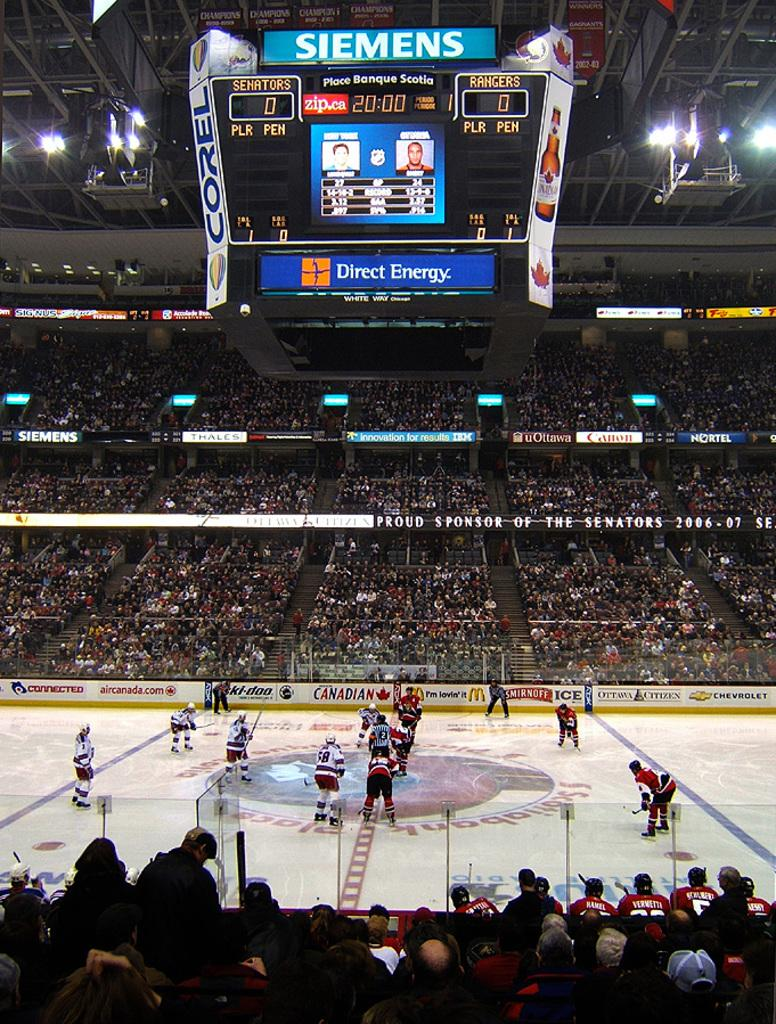<image>
Offer a succinct explanation of the picture presented. a scoreboard in a hockey arena that says 'siemens' on top 